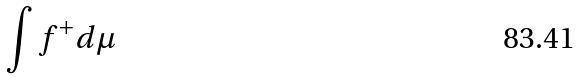<formula> <loc_0><loc_0><loc_500><loc_500>\int f ^ { + } d \mu</formula> 